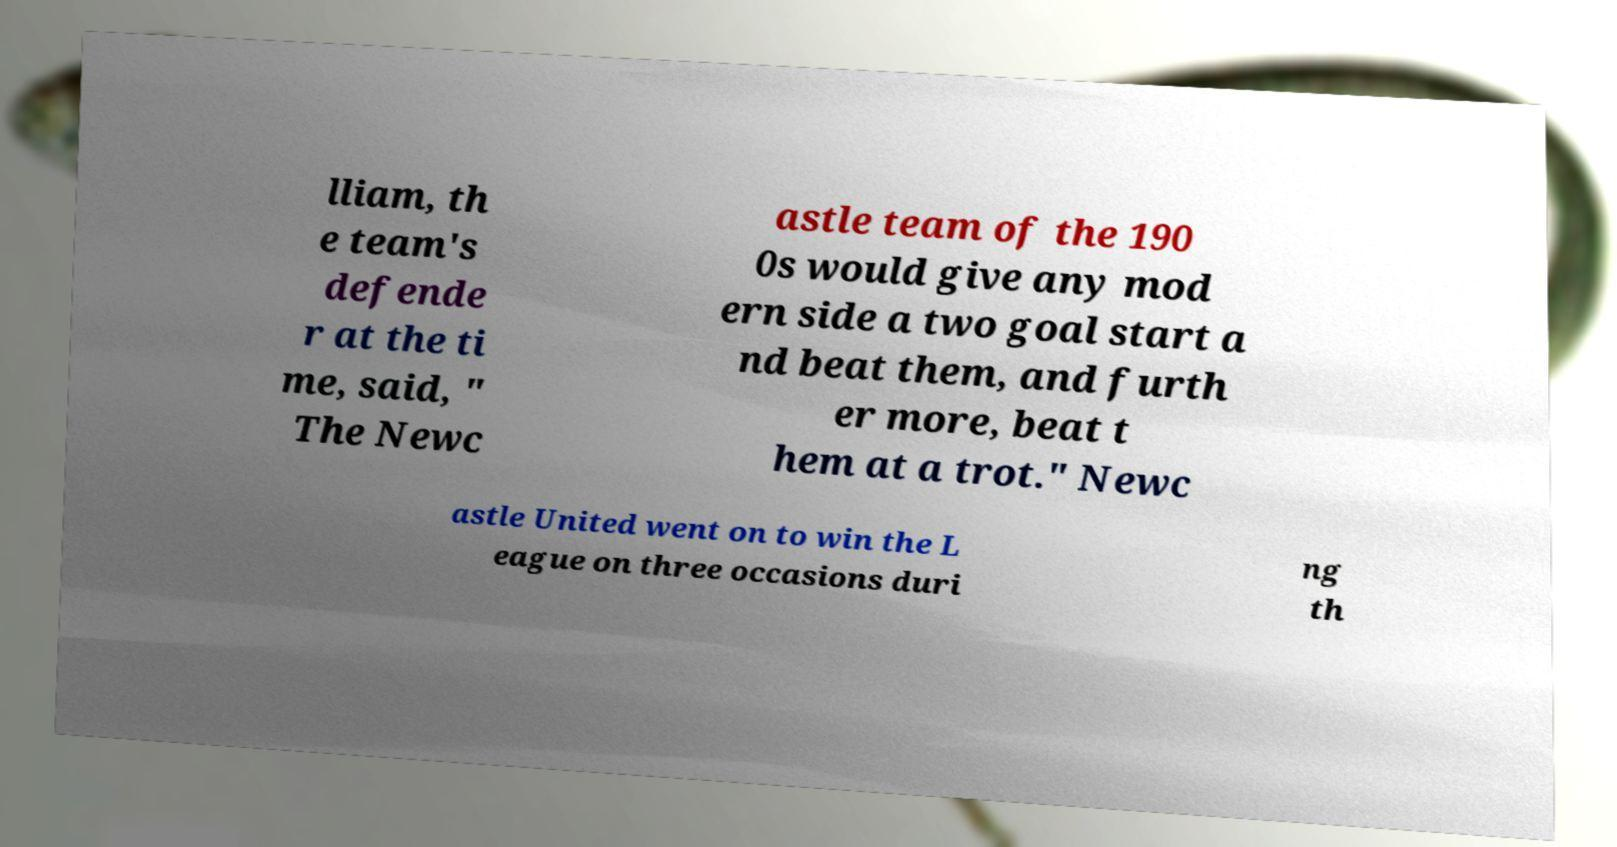Please read and relay the text visible in this image. What does it say? lliam, th e team's defende r at the ti me, said, " The Newc astle team of the 190 0s would give any mod ern side a two goal start a nd beat them, and furth er more, beat t hem at a trot." Newc astle United went on to win the L eague on three occasions duri ng th 